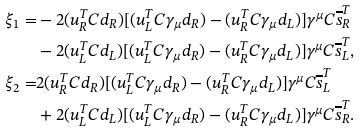Convert formula to latex. <formula><loc_0><loc_0><loc_500><loc_500>\xi _ { 1 } = & - 2 ( u ^ { T } _ { R } C d _ { R } ) [ ( u ^ { T } _ { L } C \gamma _ { \mu } d _ { R } ) - ( u ^ { T } _ { R } C \gamma _ { \mu } d _ { L } ) ] \gamma ^ { \mu } C \overline { s } ^ { T } _ { R } \\ & - 2 ( u ^ { T } _ { L } C d _ { L } ) [ ( u ^ { T } _ { L } C \gamma _ { \mu } d _ { R } ) - ( u ^ { T } _ { R } C \gamma _ { \mu } d _ { L } ) ] \gamma ^ { \mu } C \overline { s } ^ { T } _ { L } , \\ \xi _ { 2 } = & 2 ( u ^ { T } _ { R } C d _ { R } ) [ ( u ^ { T } _ { L } C \gamma _ { \mu } d _ { R } ) - ( u ^ { T } _ { R } C \gamma _ { \mu } d _ { L } ) ] \gamma ^ { \mu } C \overline { s } ^ { T } _ { L } \\ & + 2 ( u ^ { T } _ { L } C d _ { L } ) [ ( u ^ { T } _ { L } C \gamma _ { \mu } d _ { R } ) - ( u ^ { T } _ { R } C \gamma _ { \mu } d _ { L } ) ] \gamma ^ { \mu } C \overline { s } ^ { T } _ { R } .</formula> 